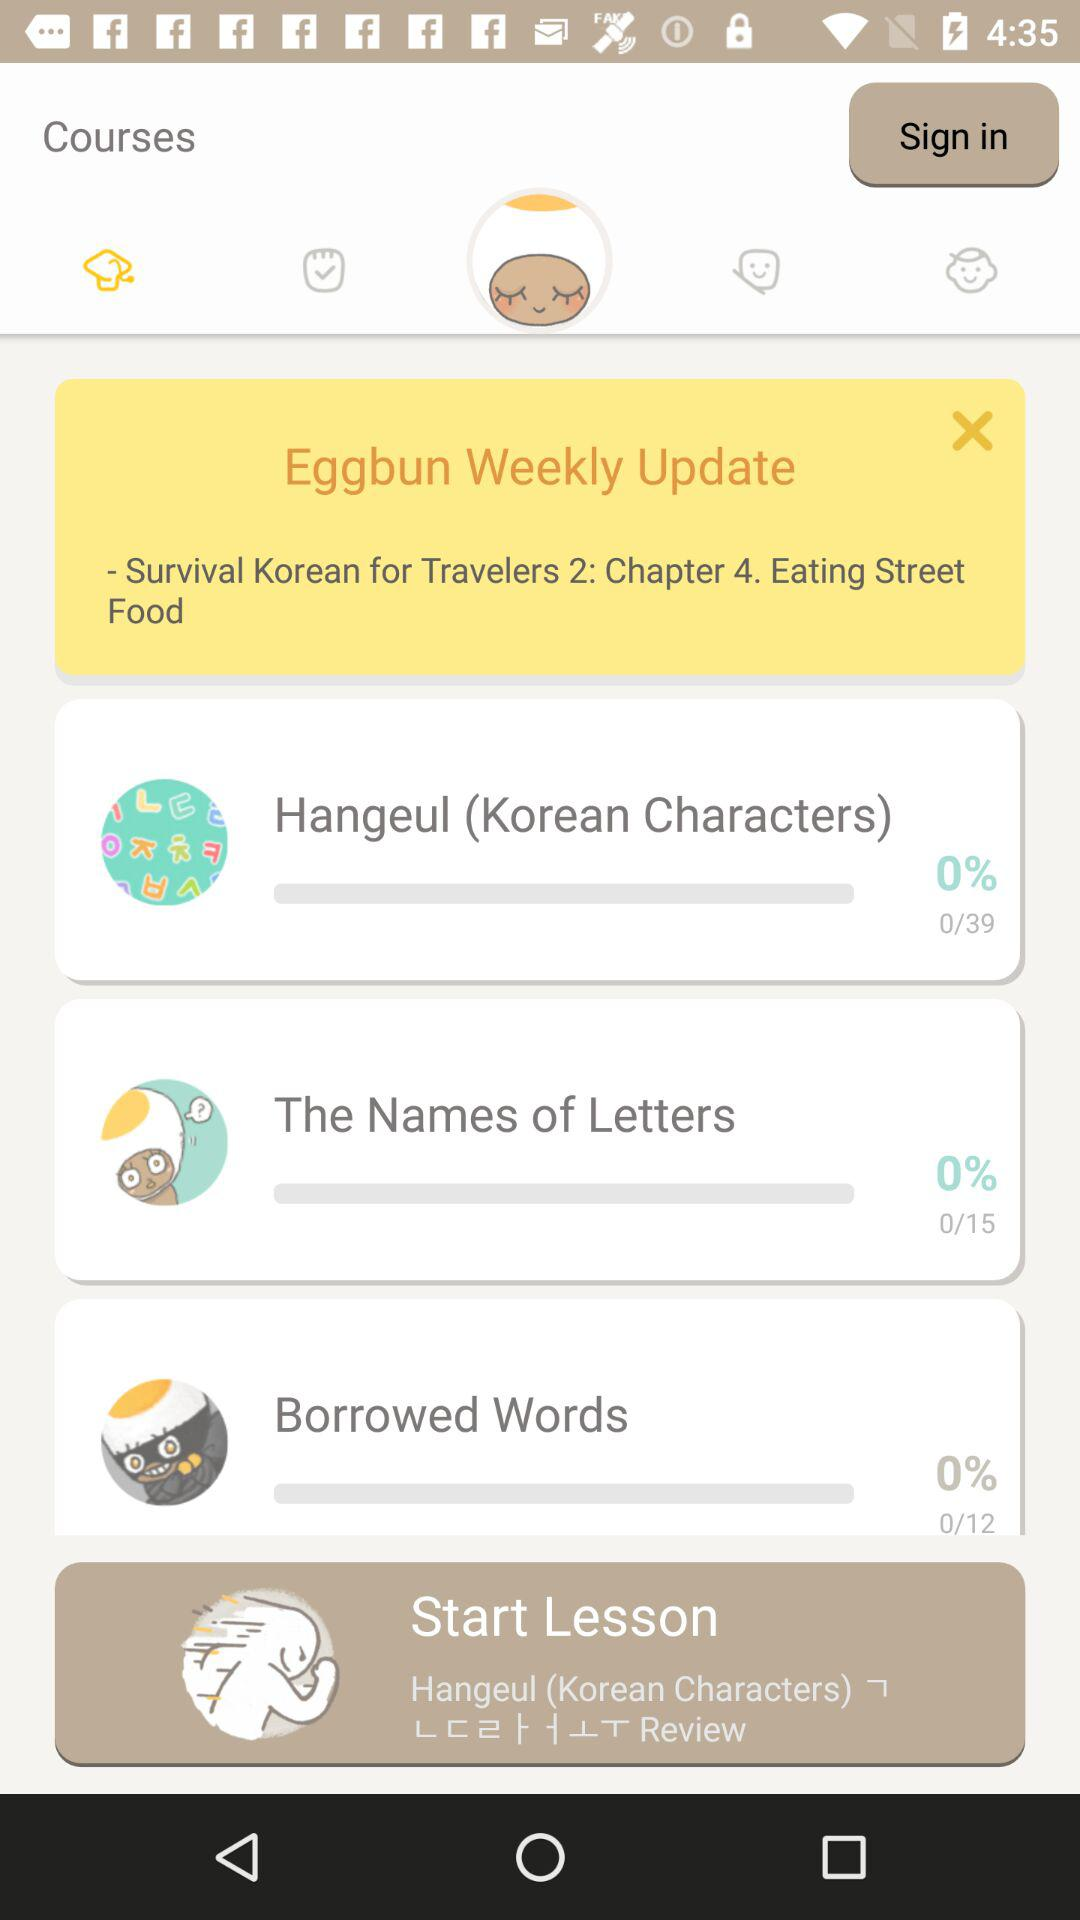What chapter is "Survival Korean for Travelers 2"? The chapter number is 4. 